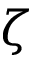<formula> <loc_0><loc_0><loc_500><loc_500>\zeta</formula> 